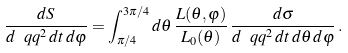<formula> <loc_0><loc_0><loc_500><loc_500>\frac { d S } { d \ q q ^ { 2 } \, d t \, d \varphi } = \int _ { \pi / 4 } ^ { 3 \pi / 4 } d \theta \, \frac { L ( \theta , \varphi ) } { L _ { 0 } ( \theta ) } \, \frac { d \sigma } { d \ q q ^ { 2 } \, d t \, d \theta \, d \varphi } \, .</formula> 